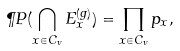<formula> <loc_0><loc_0><loc_500><loc_500>\P P ( \bigcap _ { x \in C _ { v } } E _ { x } ^ { ( g ) } ) = \prod _ { x \in C _ { v } } p _ { x } ,</formula> 